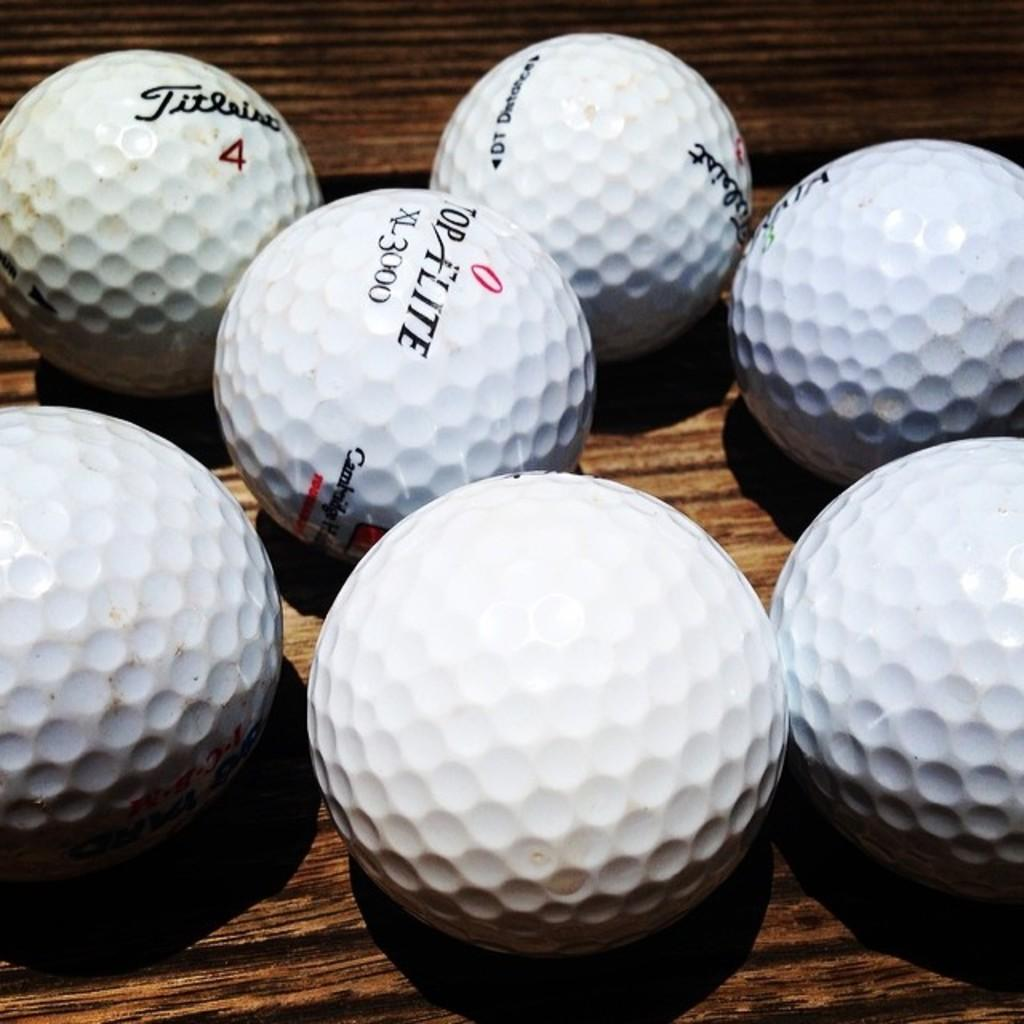What objects are present in the image? There are golf balls in the image. What type of surface are the golf balls placed on? The golf balls are on a wooden surface. What is the texture of the turkey in the image? There is no turkey present in the image; it only features golf balls on a wooden surface. 